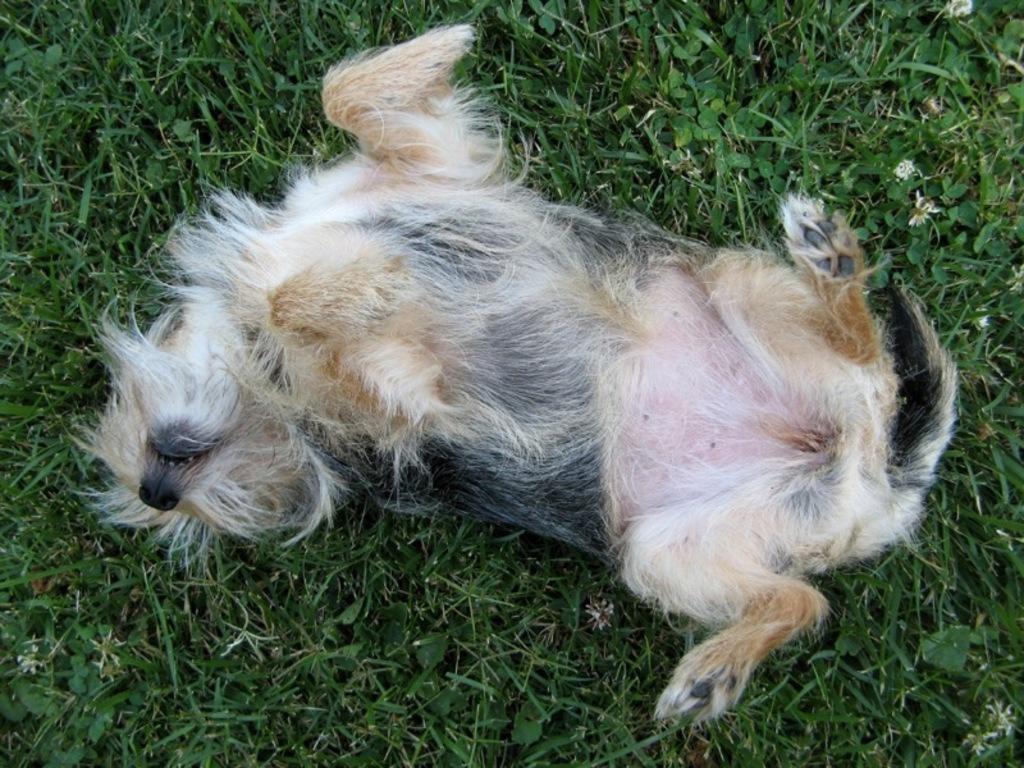Please provide a concise description of this image. There is a dog in white and black color combination, lying on the ground. On the ground, there is grass. 